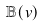<formula> <loc_0><loc_0><loc_500><loc_500>\mathbb { B } ( v )</formula> 